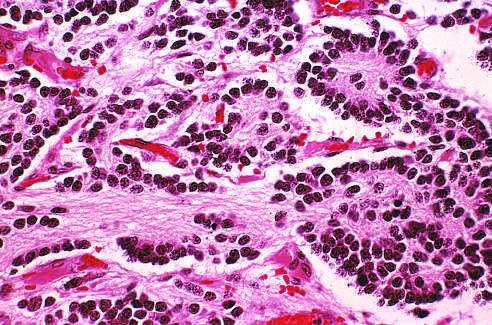what is composed of small cells embedded in a finely fibrillar matrix?
Answer the question using a single word or phrase. The tumor 